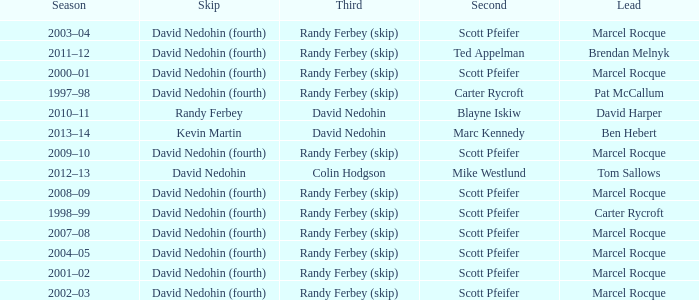Which Lead has a Third of randy ferbey (skip), a Second of scott pfeifer, and a Season of 2009–10? Marcel Rocque. Could you parse the entire table? {'header': ['Season', 'Skip', 'Third', 'Second', 'Lead'], 'rows': [['2003–04', 'David Nedohin (fourth)', 'Randy Ferbey (skip)', 'Scott Pfeifer', 'Marcel Rocque'], ['2011–12', 'David Nedohin (fourth)', 'Randy Ferbey (skip)', 'Ted Appelman', 'Brendan Melnyk'], ['2000–01', 'David Nedohin (fourth)', 'Randy Ferbey (skip)', 'Scott Pfeifer', 'Marcel Rocque'], ['1997–98', 'David Nedohin (fourth)', 'Randy Ferbey (skip)', 'Carter Rycroft', 'Pat McCallum'], ['2010–11', 'Randy Ferbey', 'David Nedohin', 'Blayne Iskiw', 'David Harper'], ['2013–14', 'Kevin Martin', 'David Nedohin', 'Marc Kennedy', 'Ben Hebert'], ['2009–10', 'David Nedohin (fourth)', 'Randy Ferbey (skip)', 'Scott Pfeifer', 'Marcel Rocque'], ['2012–13', 'David Nedohin', 'Colin Hodgson', 'Mike Westlund', 'Tom Sallows'], ['2008–09', 'David Nedohin (fourth)', 'Randy Ferbey (skip)', 'Scott Pfeifer', 'Marcel Rocque'], ['1998–99', 'David Nedohin (fourth)', 'Randy Ferbey (skip)', 'Scott Pfeifer', 'Carter Rycroft'], ['2007–08', 'David Nedohin (fourth)', 'Randy Ferbey (skip)', 'Scott Pfeifer', 'Marcel Rocque'], ['2004–05', 'David Nedohin (fourth)', 'Randy Ferbey (skip)', 'Scott Pfeifer', 'Marcel Rocque'], ['2001–02', 'David Nedohin (fourth)', 'Randy Ferbey (skip)', 'Scott Pfeifer', 'Marcel Rocque'], ['2002–03', 'David Nedohin (fourth)', 'Randy Ferbey (skip)', 'Scott Pfeifer', 'Marcel Rocque']]} 